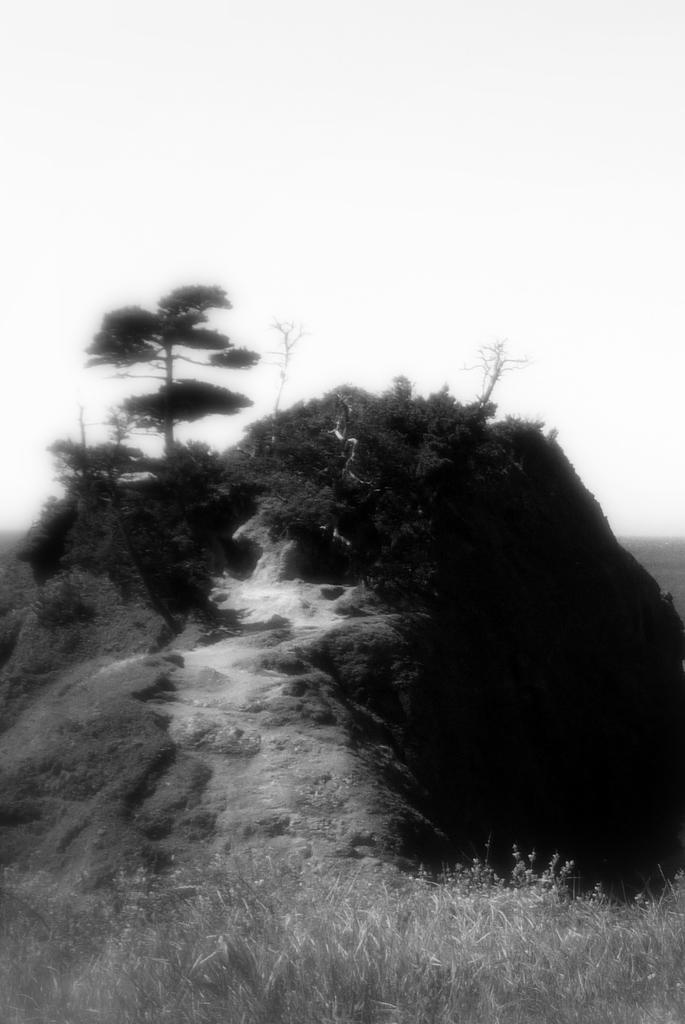Can you describe this image briefly? It is a black and white image, there is a hill and on the hill there are plenty of trees and plants below the hill there is a lot of grass. 